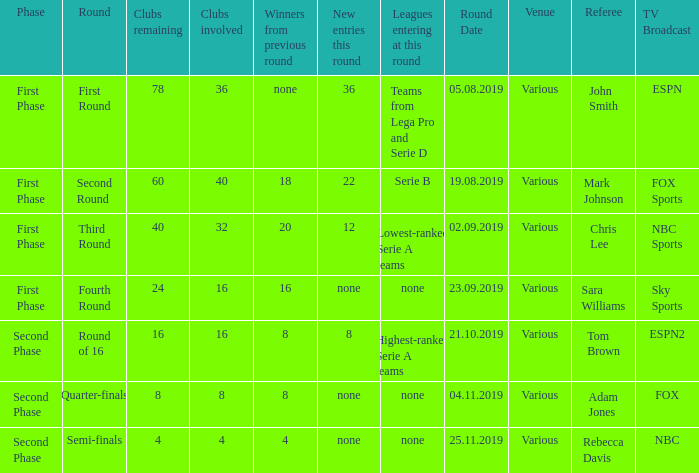The new entries this round was shown to be 12, in which phase would you find this? First Phase. 